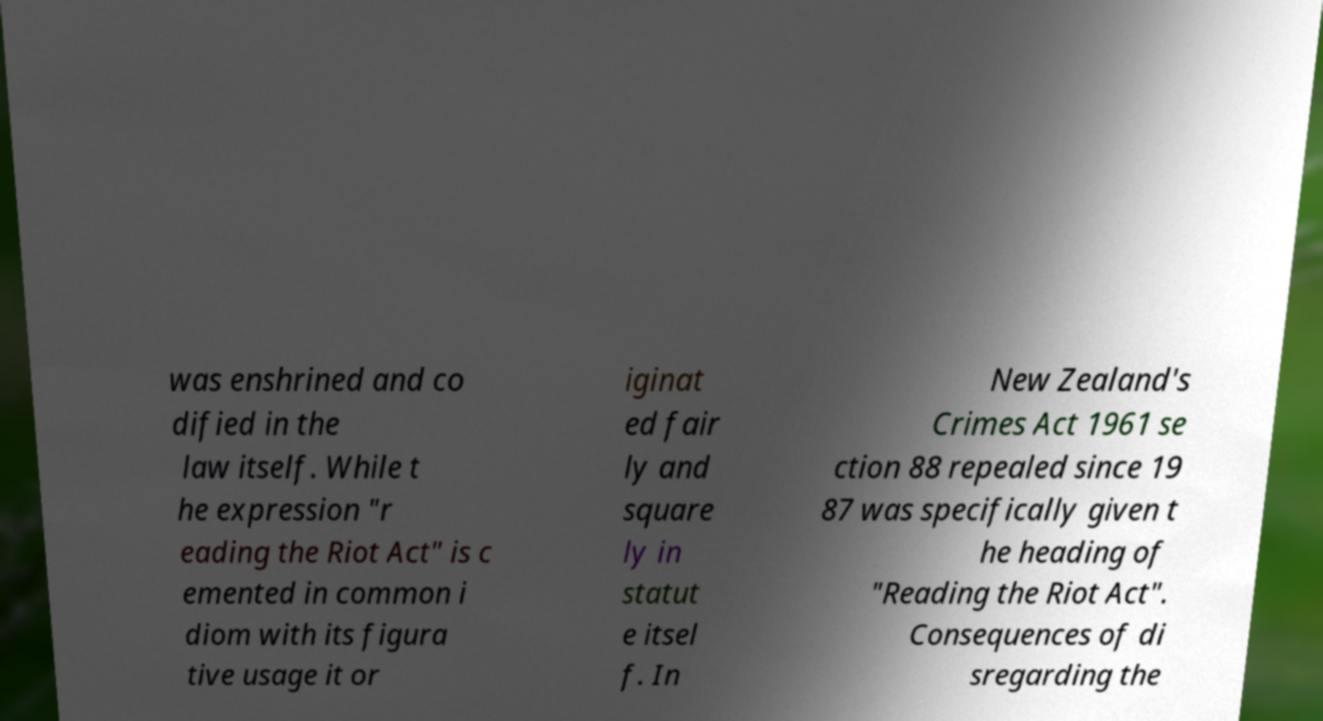There's text embedded in this image that I need extracted. Can you transcribe it verbatim? was enshrined and co dified in the law itself. While t he expression "r eading the Riot Act" is c emented in common i diom with its figura tive usage it or iginat ed fair ly and square ly in statut e itsel f. In New Zealand's Crimes Act 1961 se ction 88 repealed since 19 87 was specifically given t he heading of "Reading the Riot Act". Consequences of di sregarding the 